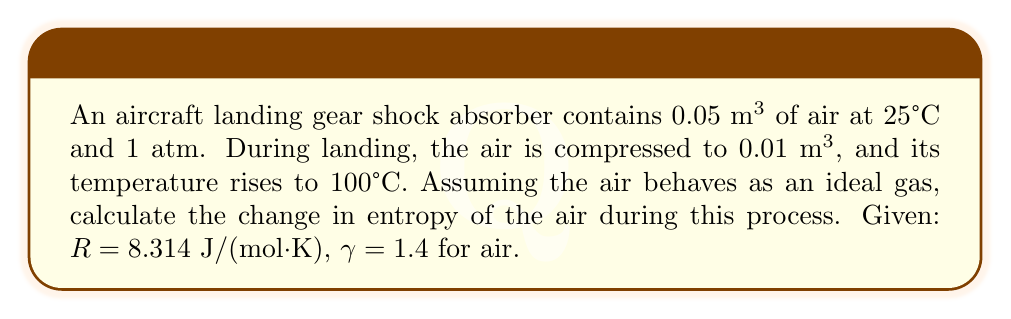Could you help me with this problem? To solve this problem, we'll follow these steps:

1) First, we need to find the number of moles of air in the shock absorber. We can use the ideal gas equation:

   $$PV = nRT$$

   At initial conditions: $P_1 = 1 \text{ atm} = 101325 \text{ Pa}$, $V_1 = 0.05 \text{ m}^3$, $T_1 = 25°C = 298 \text{ K}$

   $$n = \frac{P_1V_1}{RT_1} = \frac{101325 \cdot 0.05}{8.314 \cdot 298} = 2.05 \text{ mol}$$

2) The entropy change for an ideal gas can be calculated using the equation:

   $$\Delta S = nC_v \ln(\frac{T_2}{T_1}) + nR \ln(\frac{V_2}{V_1})$$

   Where $C_v$ is the specific heat capacity at constant volume.

3) For an ideal gas, $C_v = \frac{R}{\gamma - 1}$. For air, $\gamma = 1.4$, so:

   $$C_v = \frac{8.314}{0.4} = 20.785 \text{ J/(mol·K)}$$

4) Now we can substitute all values into the entropy change equation:

   $$\Delta S = 2.05 \cdot 20.785 \ln(\frac{373}{298}) + 2.05 \cdot 8.314 \ln(\frac{0.01}{0.05})$$

5) Calculating:

   $$\Delta S = 42.61 \ln(1.252) - 17.04 \ln(5)$$
   $$\Delta S = 9.22 - 27.43 = -18.21 \text{ J/K}$$

The negative value indicates a decrease in entropy, which is expected for a compression process.
Answer: $-18.21 \text{ J/K}$ 